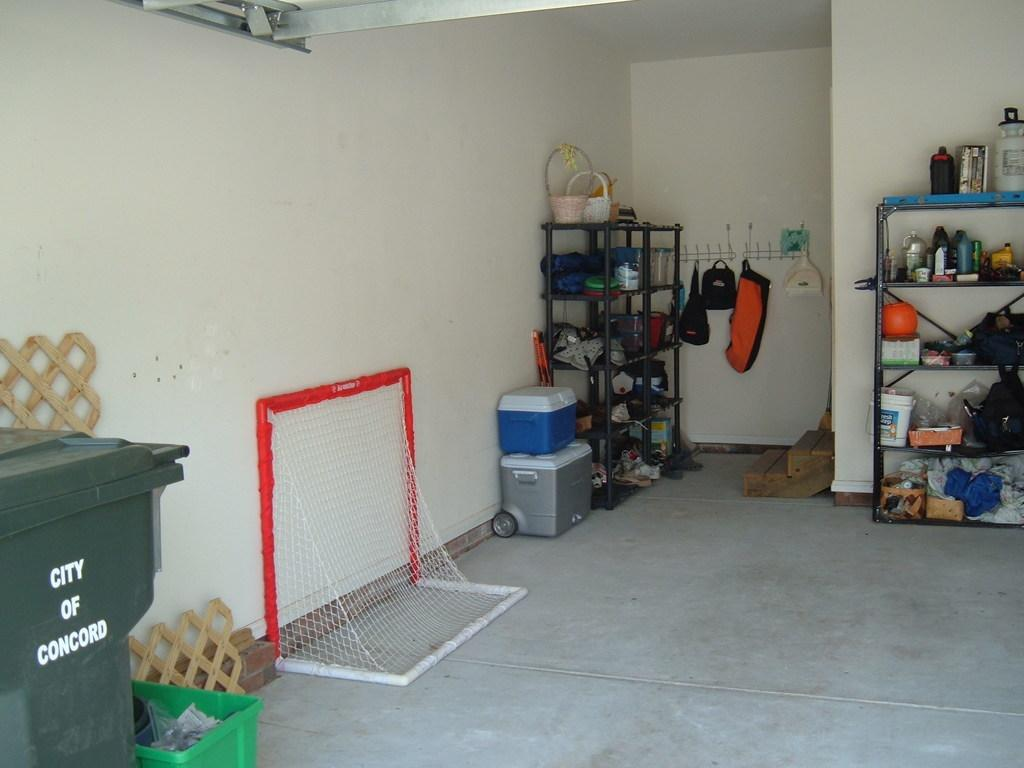<image>
Relay a brief, clear account of the picture shown. A picture of a garage inside with a garbage can that says CITY OF CONCORD. 